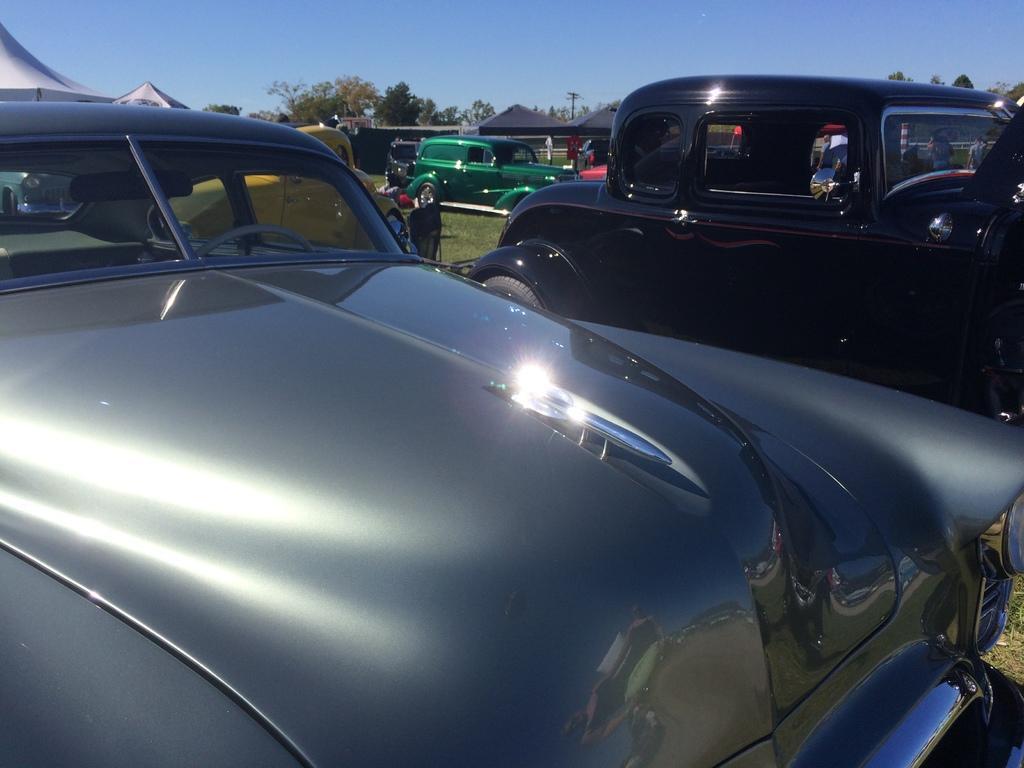In one or two sentences, can you explain what this image depicts? In this image I can see few vehicles. In front the vehicle is in silver color, background I can see an electric pole, trees in green color and the sky is in blue color. 